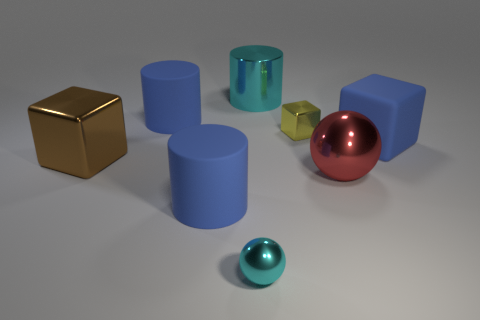Do the cyan object in front of the red sphere and the red shiny object on the right side of the tiny shiny ball have the same shape?
Your response must be concise. Yes. Are there any blue matte blocks that have the same size as the shiny cylinder?
Offer a very short reply. Yes. What is the material of the block that is to the left of the small yellow object?
Your answer should be compact. Metal. Do the ball that is to the right of the cyan cylinder and the brown object have the same material?
Your answer should be very brief. Yes. Are any big red shiny objects visible?
Keep it short and to the point. Yes. What is the color of the large sphere that is the same material as the tiny sphere?
Offer a terse response. Red. What color is the metal thing that is on the left side of the big blue matte cylinder that is behind the shiny cube that is behind the large matte cube?
Your answer should be very brief. Brown. Is the size of the brown block the same as the metal sphere right of the big cyan metal cylinder?
Your answer should be very brief. Yes. What number of objects are either cyan metal objects in front of the big red shiny ball or rubber objects right of the tiny cyan object?
Your response must be concise. 2. What is the shape of the cyan object that is the same size as the yellow metal cube?
Provide a succinct answer. Sphere. 